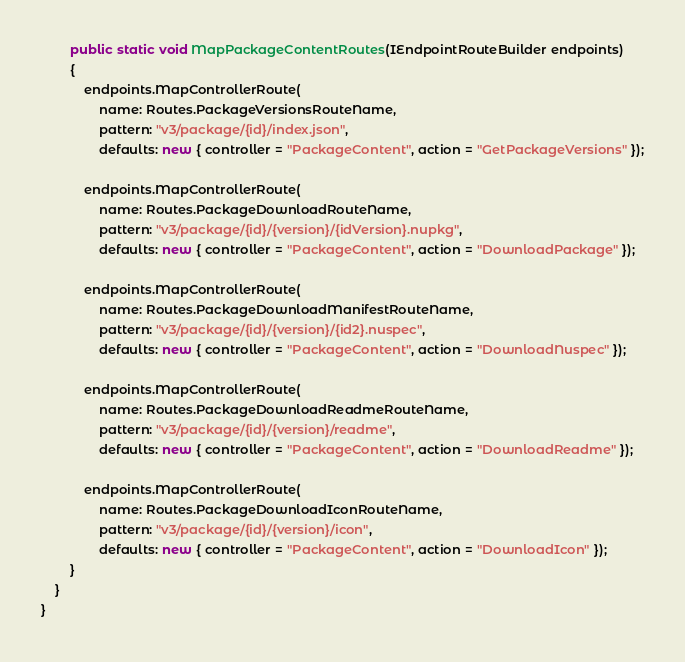Convert code to text. <code><loc_0><loc_0><loc_500><loc_500><_C#_>
        public static void MapPackageContentRoutes(IEndpointRouteBuilder endpoints)
        {
            endpoints.MapControllerRoute(
                name: Routes.PackageVersionsRouteName,
                pattern: "v3/package/{id}/index.json",
                defaults: new { controller = "PackageContent", action = "GetPackageVersions" });

            endpoints.MapControllerRoute(
                name: Routes.PackageDownloadRouteName,
                pattern: "v3/package/{id}/{version}/{idVersion}.nupkg",
                defaults: new { controller = "PackageContent", action = "DownloadPackage" });

            endpoints.MapControllerRoute(
                name: Routes.PackageDownloadManifestRouteName,
                pattern: "v3/package/{id}/{version}/{id2}.nuspec",
                defaults: new { controller = "PackageContent", action = "DownloadNuspec" });

            endpoints.MapControllerRoute(
                name: Routes.PackageDownloadReadmeRouteName,
                pattern: "v3/package/{id}/{version}/readme",
                defaults: new { controller = "PackageContent", action = "DownloadReadme" });

            endpoints.MapControllerRoute(
                name: Routes.PackageDownloadIconRouteName,
                pattern: "v3/package/{id}/{version}/icon",
                defaults: new { controller = "PackageContent", action = "DownloadIcon" });
        }
    }
}
</code> 